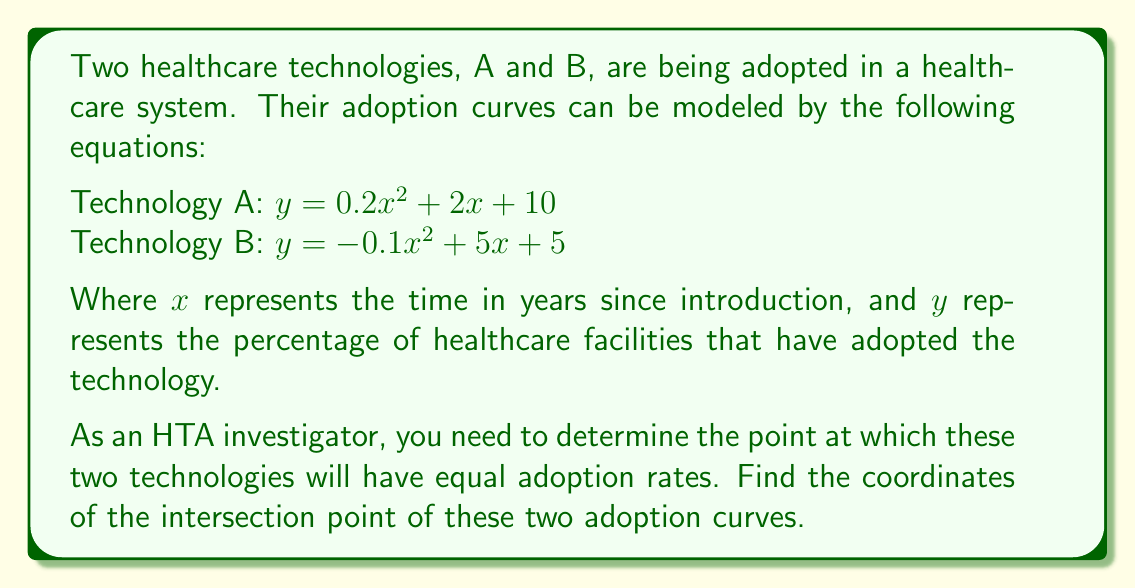Provide a solution to this math problem. To find the intersection point of the two adoption curves, we need to solve the equation where both curves have the same y-value:

1) Set the equations equal to each other:
   $0.2x^2 + 2x + 10 = -0.1x^2 + 5x + 5$

2) Rearrange the equation to standard form:
   $0.2x^2 + 2x + 10 + 0.1x^2 - 5x - 5 = 0$
   $0.3x^2 - 3x + 5 = 0$

3) This is a quadratic equation in the form $ax^2 + bx + c = 0$, where:
   $a = 0.3$
   $b = -3$
   $c = 5$

4) We can solve this using the quadratic formula: $x = \frac{-b \pm \sqrt{b^2 - 4ac}}{2a}$

5) Substituting the values:
   $x = \frac{3 \pm \sqrt{(-3)^2 - 4(0.3)(5)}}{2(0.3)}$
   $x = \frac{3 \pm \sqrt{9 - 6}}{0.6}$
   $x = \frac{3 \pm \sqrt{3}}{0.6}$

6) This gives us two solutions:
   $x_1 = \frac{3 + \sqrt{3}}{0.6} \approx 6.88$
   $x_2 = \frac{3 - \sqrt{3}}{0.6} \approx 3.12$

7) Since time cannot be negative in this context, we only consider the positive solution. The x-coordinate of the intersection point is approximately 3.12 years.

8) To find the y-coordinate, we can substitute this x-value into either of the original equations. Let's use Technology A's equation:

   $y = 0.2(3.12)^2 + 2(3.12) + 10$
   $y \approx 1.95 + 6.24 + 10 = 18.19$

Therefore, the intersection point is approximately (3.12, 18.19).
Answer: The coordinates of the intersection point are approximately (3.12, 18.19), meaning the two healthcare technologies will have equal adoption rates of about 18.19% after approximately 3.12 years. 